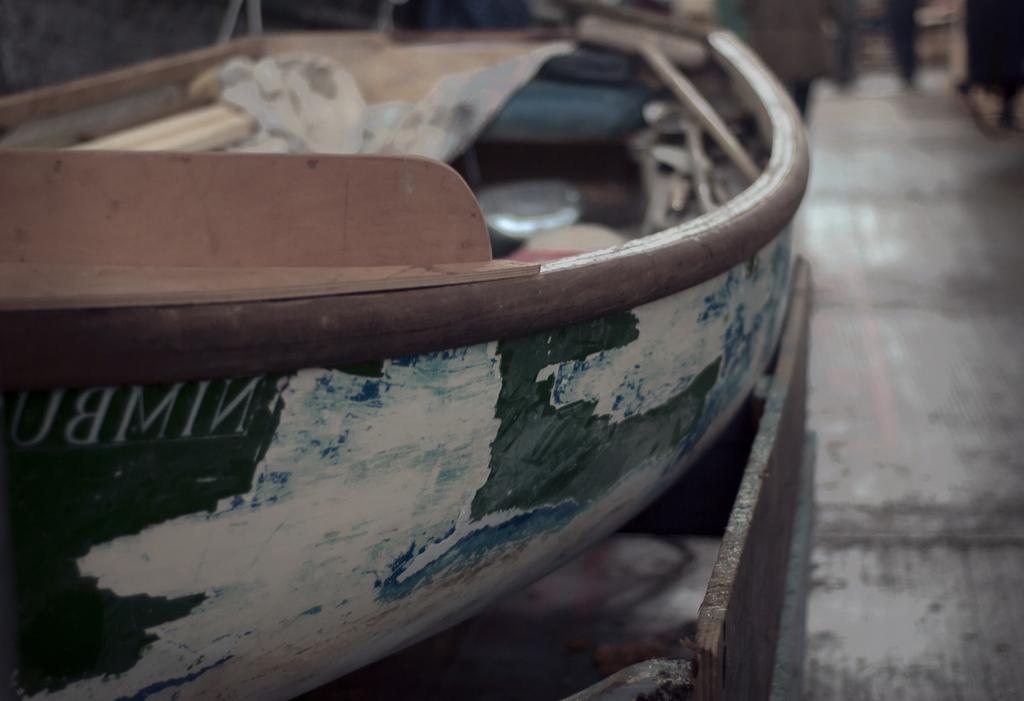How would you summarize this image in a sentence or two? In this picture there is an old boat on the left side of the image. 